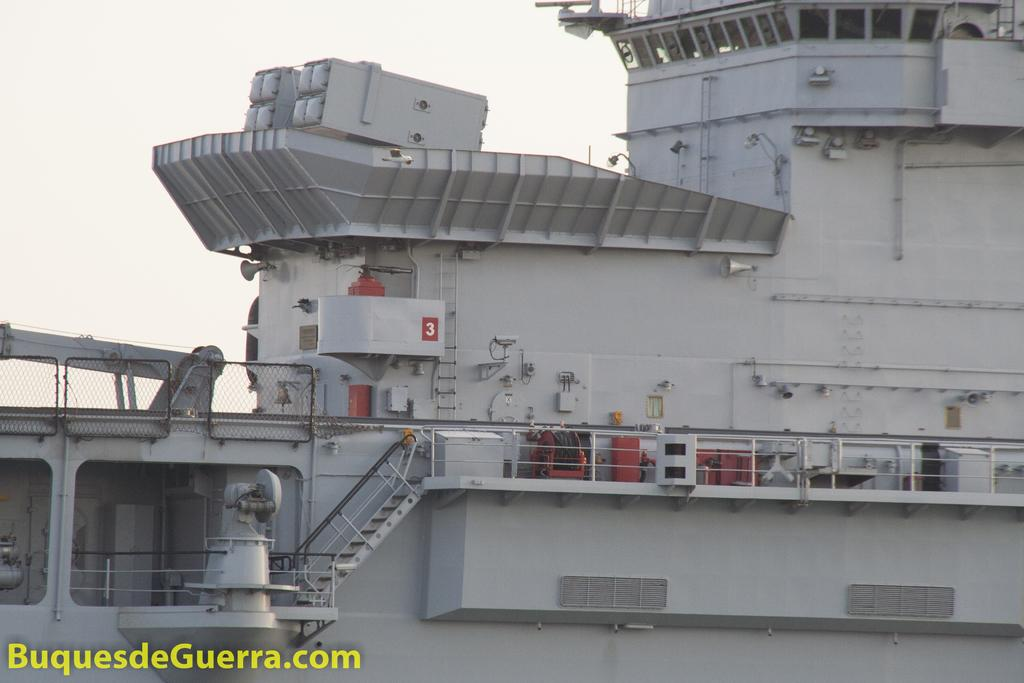What is the main subject of the image? The main subject of the image is a ship. What features can be seen on the ship? The ship has railing and stairs. Is there any text present in the image? Yes, there is text in the bottom left corner of the image. What can be seen in the background of the image? The sky is visible in the background of the image. How many planes are flying above the ship in the image? There are no planes visible in the image; it only features a ship with railing and stairs. What type of yoke is used to steer the ship in the image? There is no yoke present in the image, as ships are typically steered using a wheel or other navigational equipment. 